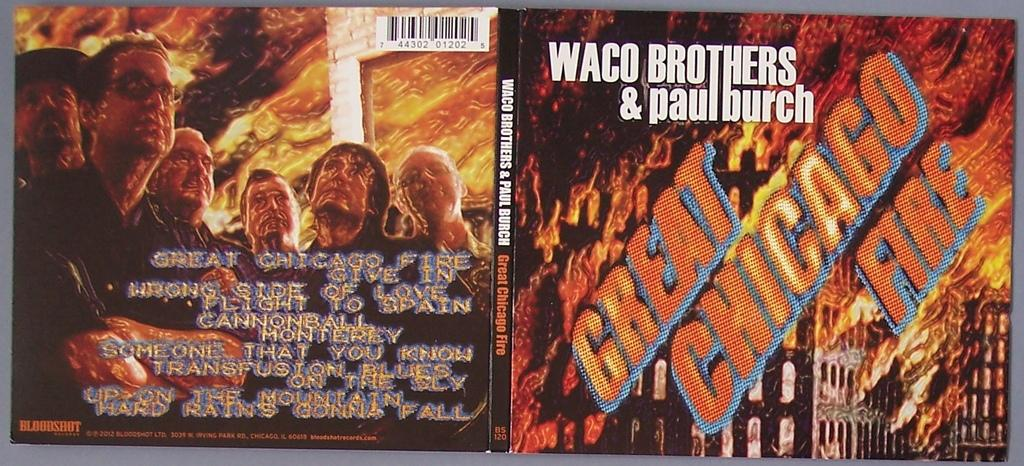Provide a one-sentence caption for the provided image. Waco Brothers & Paul Burch cover cd for the Great Chicago fire. 